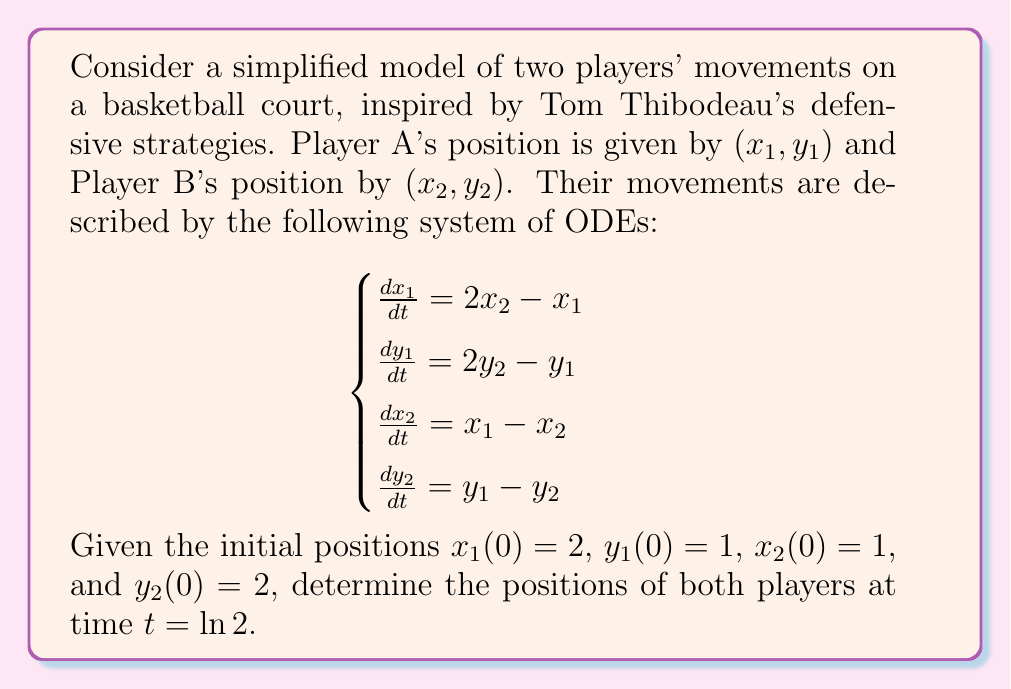Help me with this question. To solve this system of ODEs, we'll follow these steps:

1) First, we need to decouple the system. Let's focus on the $x$ coordinates (the $y$ coordinates will follow the same pattern).

2) Differentiating the first equation and substituting the third:
   $$\frac{d^2x_1}{dt^2} = 2\frac{dx_2}{dt} - \frac{dx_1}{dt} = 2(x_1 - x_2) - (2x_2 - x_1) = 3x_1 - 4x_2$$

3) Substituting the first equation into this:
   $$\frac{d^2x_1}{dt^2} = 3x_1 - 4(\frac{1}{2}(\frac{dx_1}{dt} + x_1)) = x_1 - 2\frac{dx_1}{dt}$$

4) This gives us a second-order ODE for $x_1$:
   $$\frac{d^2x_1}{dt^2} + 2\frac{dx_1}{dt} - x_1 = 0$$

5) The characteristic equation is $r^2 + 2r - 1 = 0$, with roots $r = -1$ and $r = 1$.

6) Therefore, the general solution for $x_1$ is:
   $$x_1(t) = c_1e^t + c_2e^{-t}$$

7) We can find $x_2$ from the first equation of the original system:
   $$x_2(t) = \frac{1}{2}(\frac{dx_1}{dt} + x_1) = \frac{1}{2}(c_1e^t - c_2e^{-t} + c_1e^t + c_2e^{-t}) = c_1e^t$$

8) Using the initial conditions $x_1(0) = 2$ and $x_2(0) = 1$, we get:
   $$2 = c_1 + c_2$$
   $$1 = c_1$$

9) Solving this, we get $c_1 = 1$ and $c_2 = 1$. Therefore:
   $$x_1(t) = e^t + e^{-t}$$
   $$x_2(t) = e^t$$

10) The same process for $y$ coordinates gives:
    $$y_1(t) = e^t + e^{-t}$$
    $$y_2(t) = e^t$$

11) At $t = \ln 2$, we have:
    $$x_1(\ln 2) = y_1(\ln 2) = 2 + \frac{1}{2} = \frac{5}{2}$$
    $$x_2(\ln 2) = y_2(\ln 2) = 2$$
Answer: At time $t = \ln 2$, the positions of the players are:
Player A: $(x_1, y_1) = (\frac{5}{2}, \frac{5}{2})$
Player B: $(x_2, y_2) = (2, 2)$ 